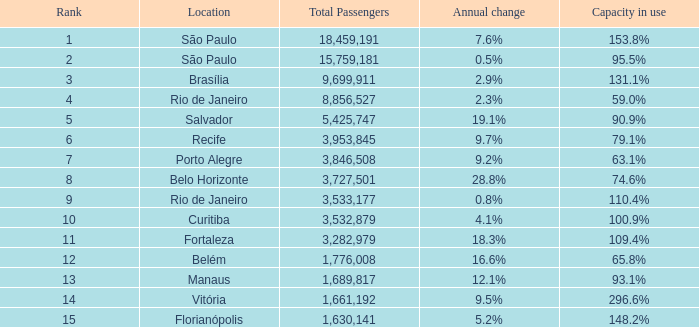8% and the ranking is under 8? 0.0. 